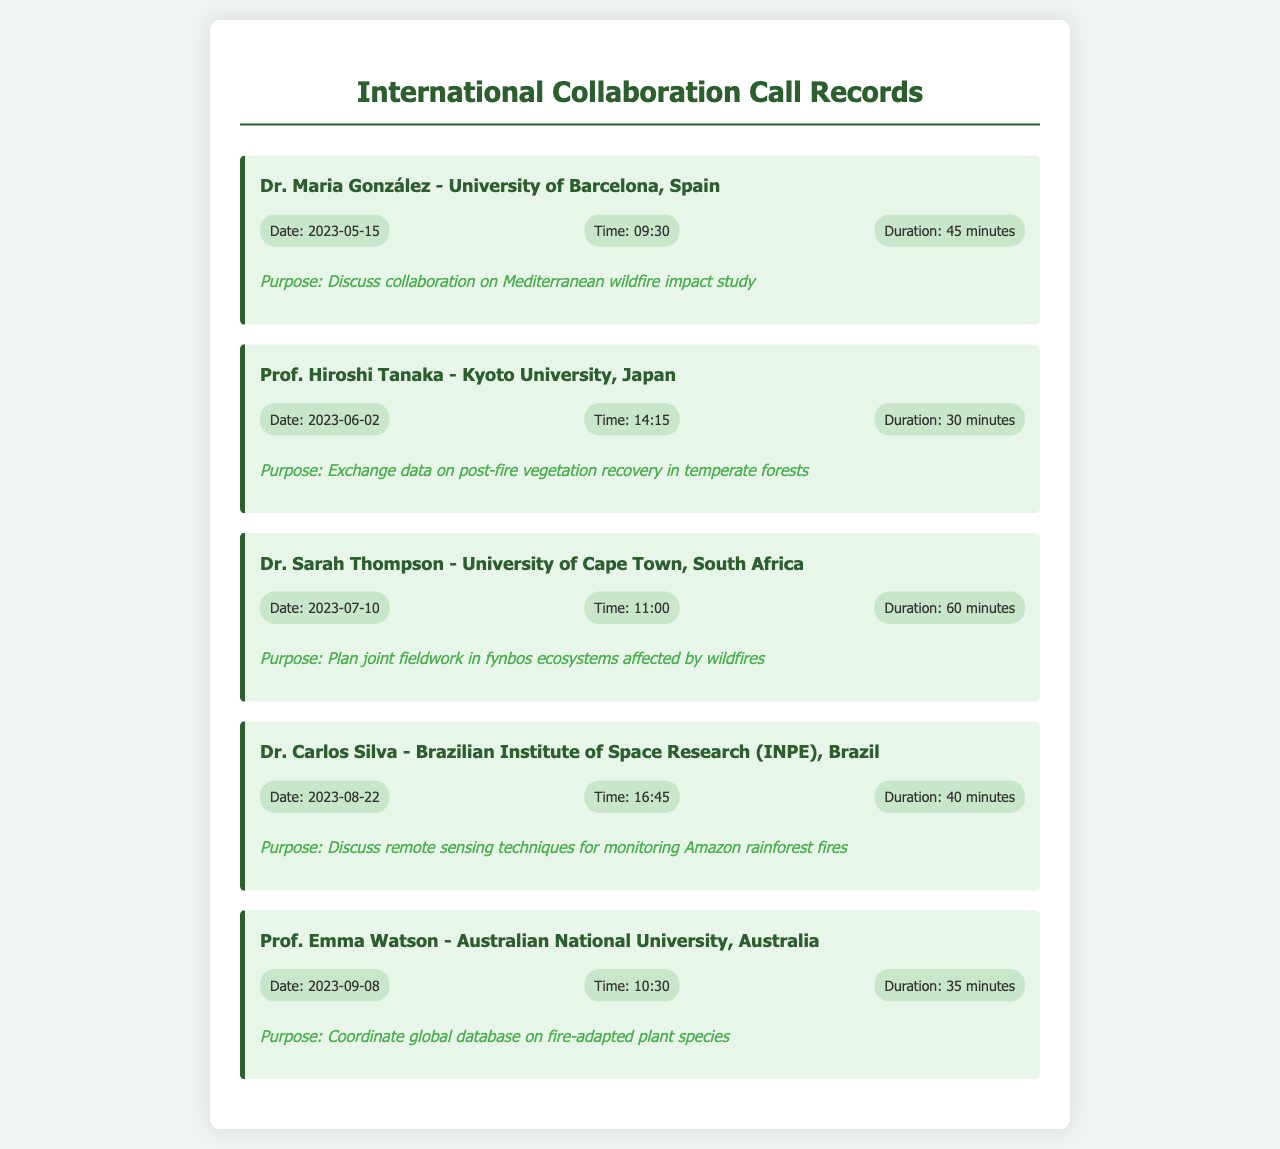What is the name of the first person mentioned? The first person mentioned in the document is Dr. Maria González.
Answer: Dr. Maria González What is the date of the call with Prof. Hiroshi Tanaka? The date of the call with Prof. Hiroshi Tanaka is June 2, 2023.
Answer: June 2, 2023 What was the purpose of the call with Dr. Sarah Thompson? The purpose of the call with Dr. Sarah Thompson was to plan joint fieldwork in fynbos ecosystems affected by wildfires.
Answer: Plan joint fieldwork in fynbos ecosystems affected by wildfires How long was the call with Dr. Carlos Silva? The duration of the call with Dr. Carlos Silva was 40 minutes.
Answer: 40 minutes Which university is Dr. Sarah Thompson affiliated with? Dr. Sarah Thompson is affiliated with the University of Cape Town.
Answer: University of Cape Town What type of study is discussed with Dr. Maria González? The study discussed with Dr. Maria González is on Mediterranean wildfire impact.
Answer: Mediterranean wildfire impact study How many minutes was the call with Prof. Emma Watson? The call with Prof. Emma Watson lasted for 35 minutes.
Answer: 35 minutes Which country does Dr. Carlos Silva represent? Dr. Carlos Silva represents Brazil.
Answer: Brazil 